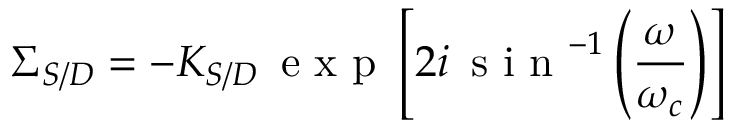<formula> <loc_0><loc_0><loc_500><loc_500>\Sigma _ { S / D } = - K _ { S / D } \, e x p \left [ 2 i \, s i n ^ { - 1 } \left ( \frac { \omega } { \omega _ { c } } \right ) \right ]</formula> 